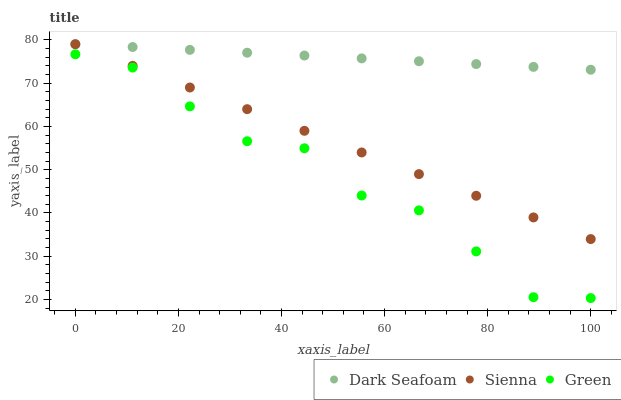Does Green have the minimum area under the curve?
Answer yes or no. Yes. Does Dark Seafoam have the maximum area under the curve?
Answer yes or no. Yes. Does Dark Seafoam have the minimum area under the curve?
Answer yes or no. No. Does Green have the maximum area under the curve?
Answer yes or no. No. Is Sienna the smoothest?
Answer yes or no. Yes. Is Green the roughest?
Answer yes or no. Yes. Is Dark Seafoam the smoothest?
Answer yes or no. No. Is Dark Seafoam the roughest?
Answer yes or no. No. Does Green have the lowest value?
Answer yes or no. Yes. Does Dark Seafoam have the lowest value?
Answer yes or no. No. Does Dark Seafoam have the highest value?
Answer yes or no. Yes. Does Green have the highest value?
Answer yes or no. No. Is Green less than Sienna?
Answer yes or no. Yes. Is Sienna greater than Green?
Answer yes or no. Yes. Does Dark Seafoam intersect Sienna?
Answer yes or no. Yes. Is Dark Seafoam less than Sienna?
Answer yes or no. No. Is Dark Seafoam greater than Sienna?
Answer yes or no. No. Does Green intersect Sienna?
Answer yes or no. No. 